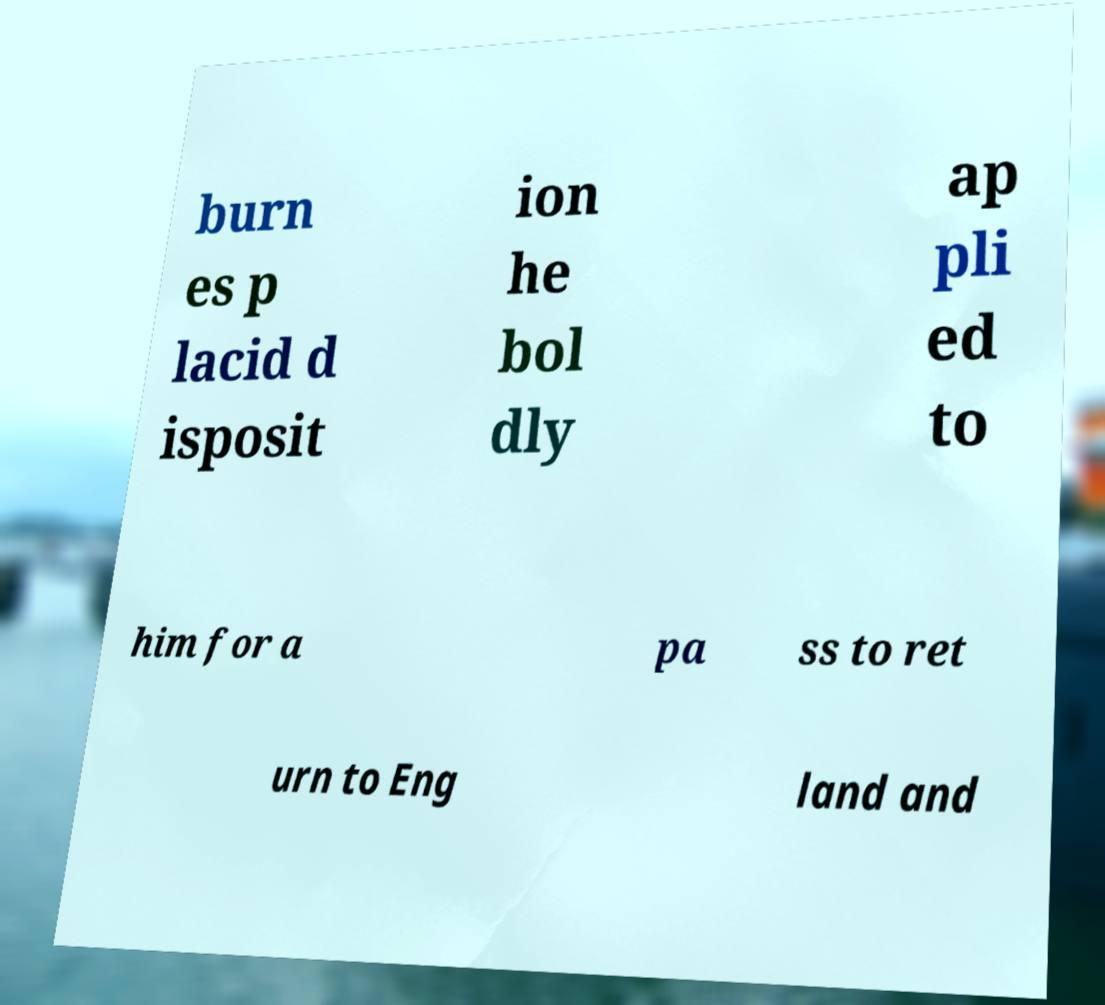Please identify and transcribe the text found in this image. burn es p lacid d isposit ion he bol dly ap pli ed to him for a pa ss to ret urn to Eng land and 